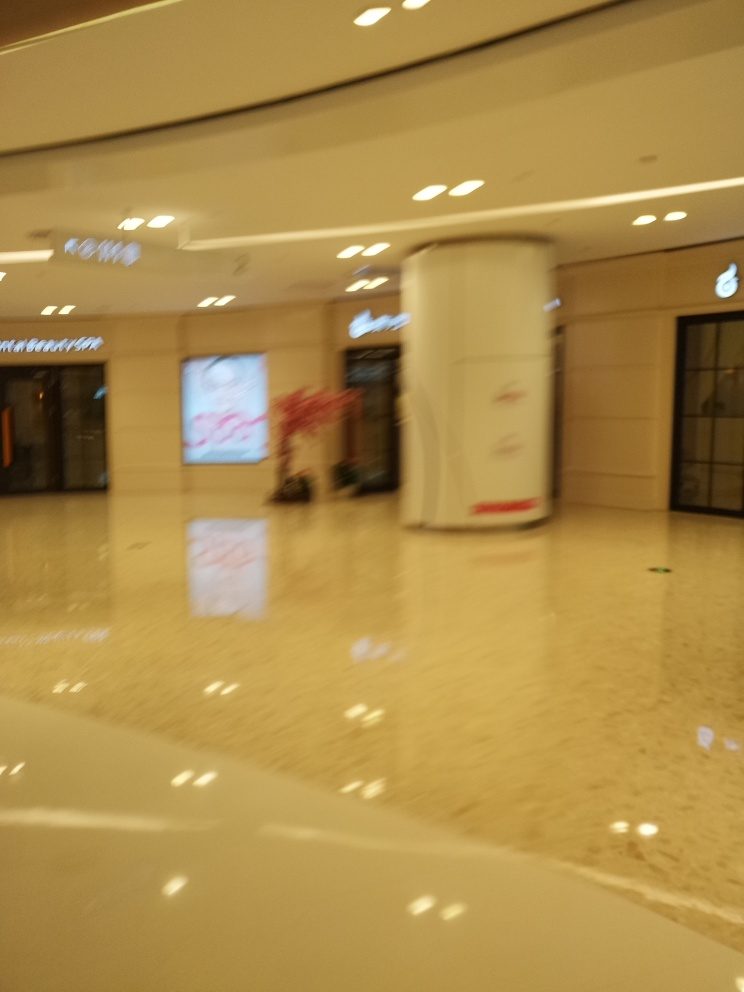Is the image of good quality? The image is of low quality as it is blurred and lacks clear details, making it difficult to discern specific features or subjects within it. 